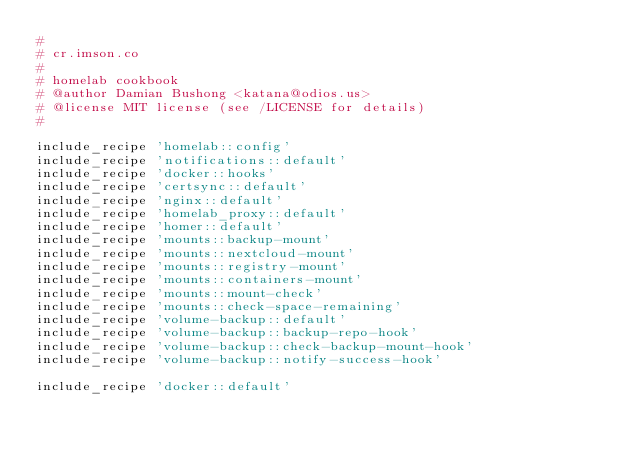Convert code to text. <code><loc_0><loc_0><loc_500><loc_500><_Ruby_>#
# cr.imson.co
#
# homelab cookbook
# @author Damian Bushong <katana@odios.us>
# @license MIT license (see /LICENSE for details)
#

include_recipe 'homelab::config'
include_recipe 'notifications::default'
include_recipe 'docker::hooks'
include_recipe 'certsync::default'
include_recipe 'nginx::default'
include_recipe 'homelab_proxy::default'
include_recipe 'homer::default'
include_recipe 'mounts::backup-mount'
include_recipe 'mounts::nextcloud-mount'
include_recipe 'mounts::registry-mount'
include_recipe 'mounts::containers-mount'
include_recipe 'mounts::mount-check'
include_recipe 'mounts::check-space-remaining'
include_recipe 'volume-backup::default'
include_recipe 'volume-backup::backup-repo-hook'
include_recipe 'volume-backup::check-backup-mount-hook'
include_recipe 'volume-backup::notify-success-hook'

include_recipe 'docker::default'
</code> 